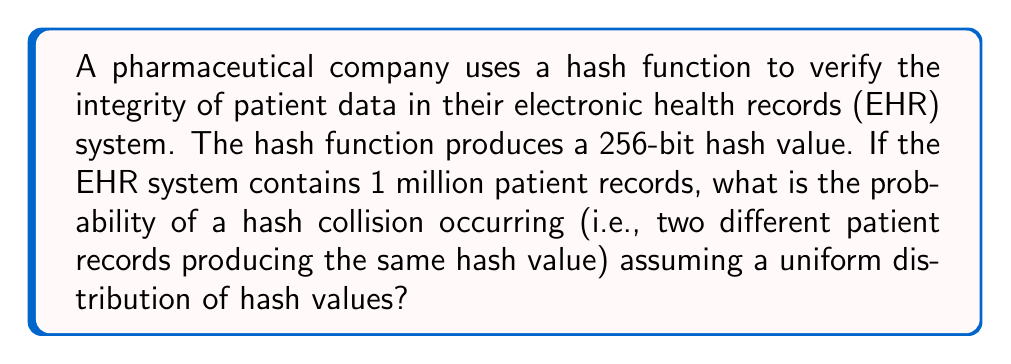Teach me how to tackle this problem. Let's approach this step-by-step:

1) First, we need to understand the birthday paradox, which is relevant to hash collisions.

2) The number of possible hash values is $2^{256}$ (as it's a 256-bit hash).

3) The number of patient records is $n = 1,000,000$.

4) The probability of a collision is approximately:

   $$P(\text{collision}) \approx 1 - e^{-\frac{n^2}{2m}}$$

   where $m$ is the number of possible hash values.

5) Substituting our values:

   $$P(\text{collision}) \approx 1 - e^{-\frac{1,000,000^2}{2 \cdot 2^{256}}}$$

6) Simplify:
   $$P(\text{collision}) \approx 1 - e^{-\frac{10^{12}}{2 \cdot 2^{256}}}$$

7) Calculate:
   $$P(\text{collision}) \approx 1 - e^{-2.7 \times 10^{-65}}$$

8) This is extremely close to zero, so we can approximate:
   $$P(\text{collision}) \approx 2.7 \times 10^{-65}$$

This extremely low probability demonstrates the effectiveness of a 256-bit hash function in maintaining data integrity for this EHR system.
Answer: $2.7 \times 10^{-65}$ 